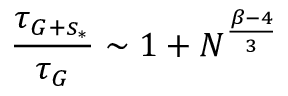<formula> <loc_0><loc_0><loc_500><loc_500>\frac { \tau _ { G + s _ { * } } } { \tau _ { G } } \sim 1 + N ^ { \frac { \beta - 4 } { 3 } }</formula> 